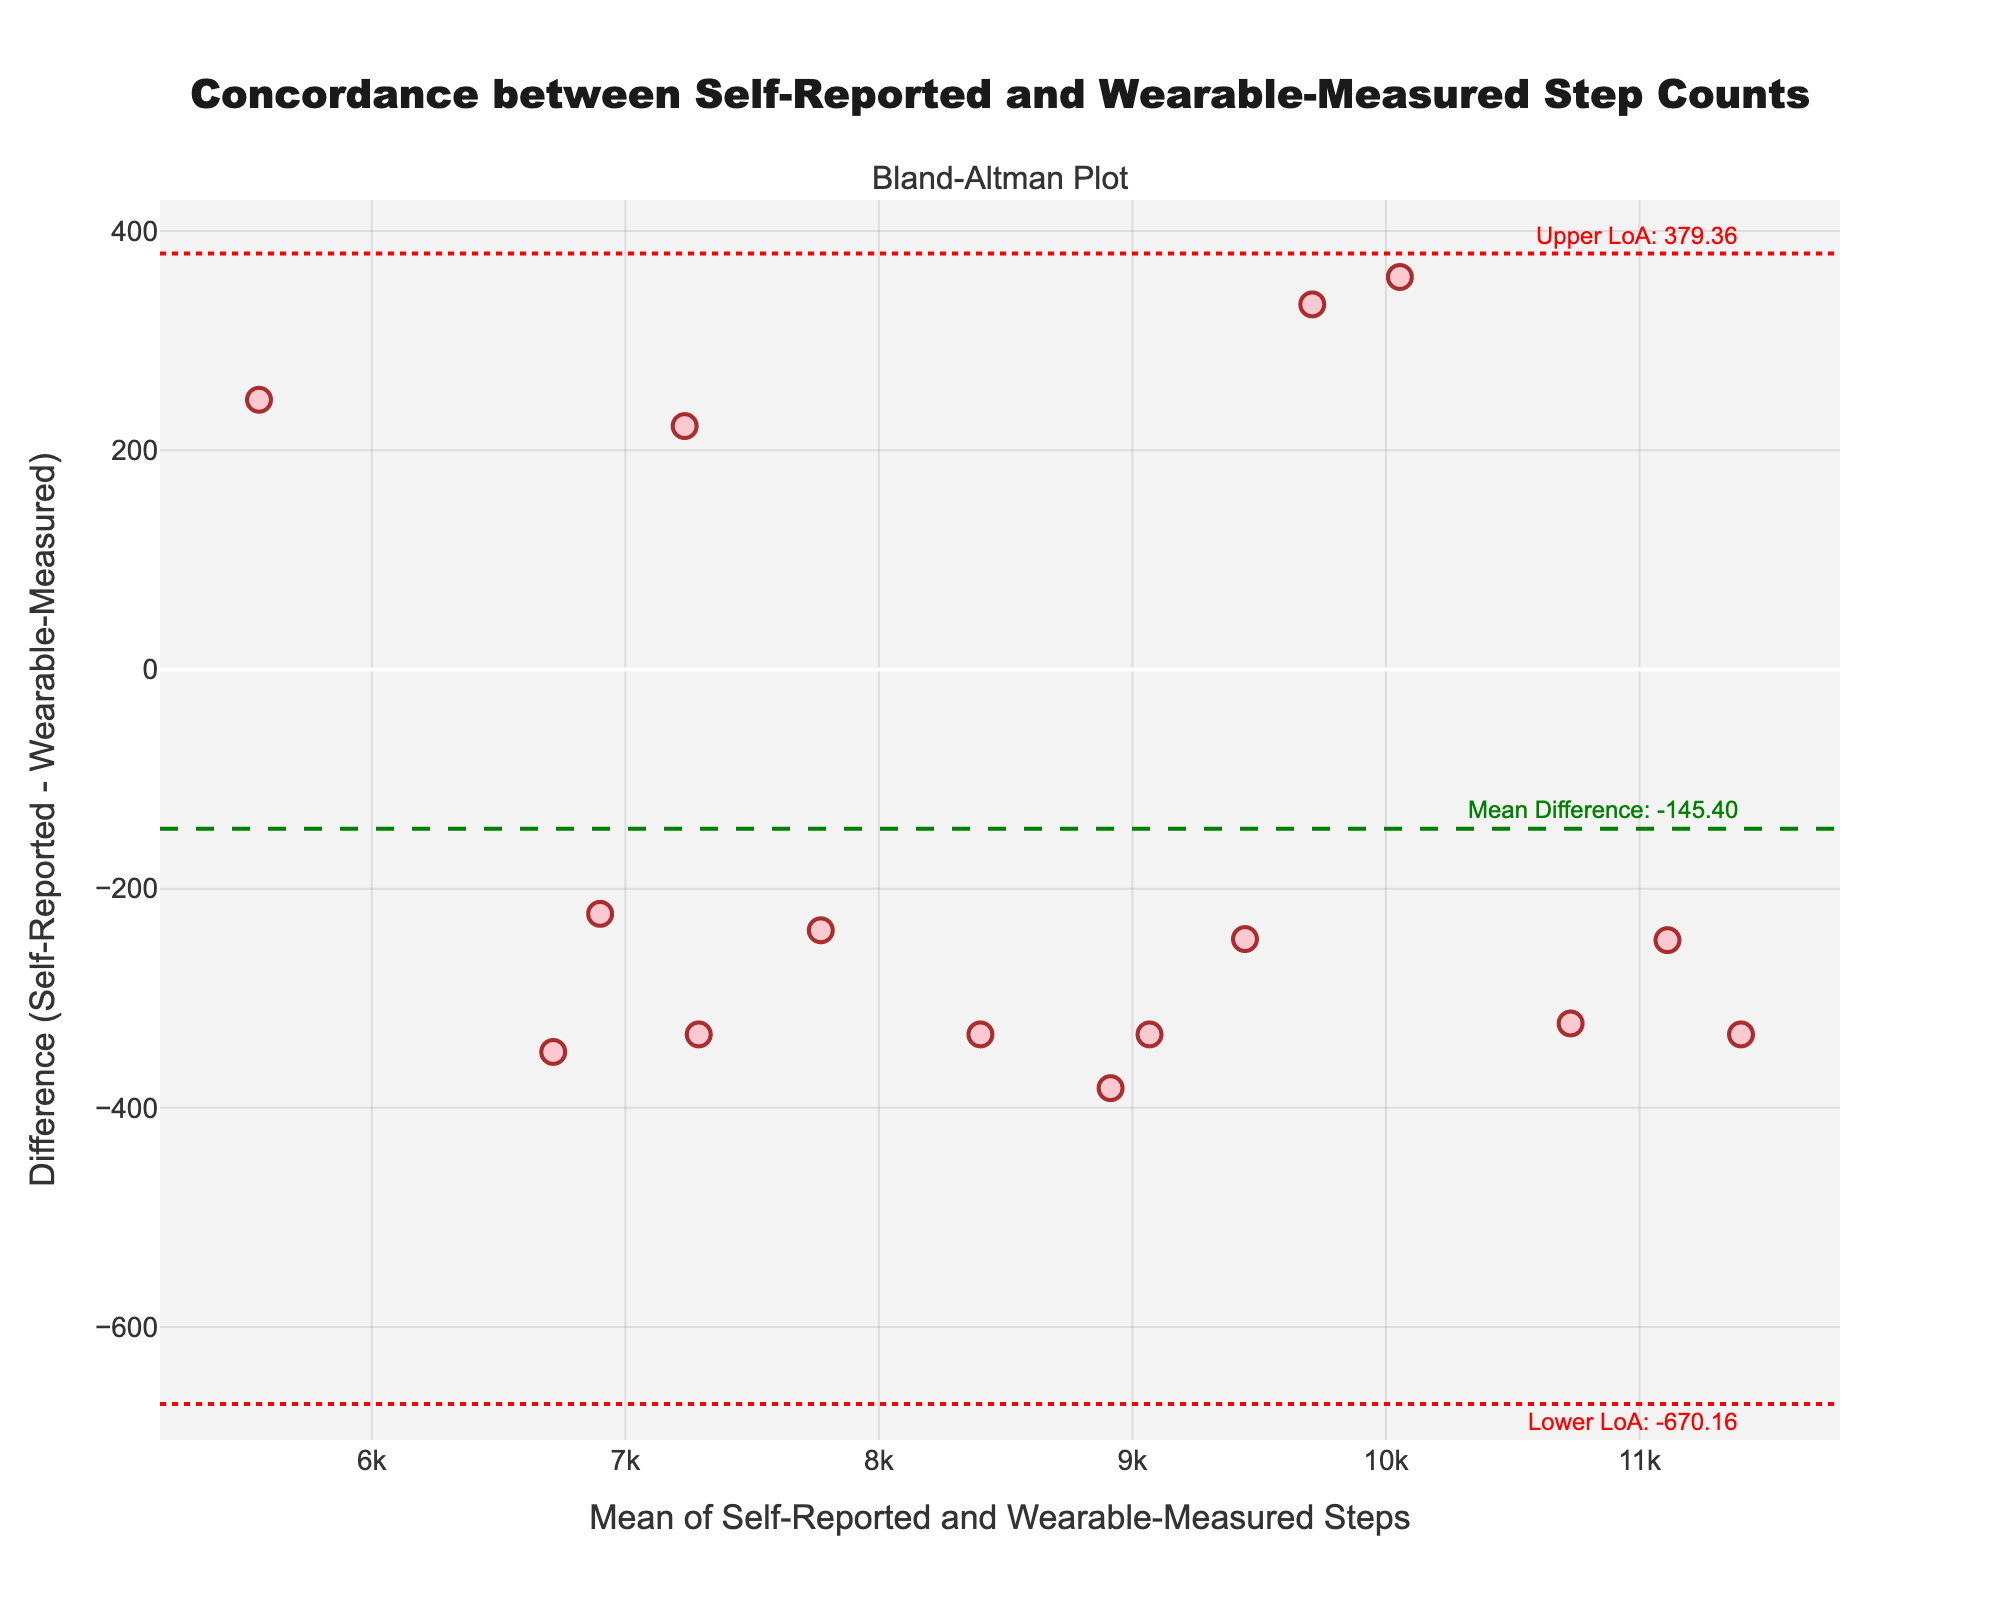How many data points are represented in the figure? Count the number of markers (data points) on the plot. The data contains 15 subjects, each contributing one data point.
Answer: 15 What is the title of the figure? The title of the figure is often at the top and centered. It states the main focus of the figure.
Answer: "Concordance between Self-Reported and Wearable-Measured Step Counts" What do the green and red dashed lines represent? The green dashed line represents the mean difference (mean discrepancy between self-reported and wearable-measured steps). The red dashed lines represent the limits of agreement (mean difference ± 1.96 standard deviations).
Answer: Mean difference and limits of agreement What is the value of the mean difference in step counts? Look at the green dashed line and the corresponding annotation at the right of the plot. The text reveals the mean difference value.
Answer: 160.13 What is the range between the upper and lower limits of agreement? Subtract the lower limit of agreement (lower red dashed line) from the upper limit of agreement (upper red dashed line).
Answer: 991.73 Who reported the highest number of steps? Find the data point with the largest mean value. Check the annotations to confirm the subject's identity.
Answer: George Taylor Which subject's self-reported steps underestimated the wearable-measured steps by the largest margin? Identify the data point with the lowest difference (most negative value). Check the corresponding annotation to confirm the subject's identity.
Answer: Fiona Wright Is there a general trend in the difference based on the mean step count? Observe whether data points above or below the mean difference line show any trend when moving from left to right on the x-axis.
Answer: No strong trend Do most data points fall within the limits of agreement? Count the number of data points that fall between the red dashed lines (limits of agreement). Compare this with the total number of data points.
Answer: Yes Which subject's data point is closest to having zero difference between self-reported and wearable-measured steps? Find the data point closest to the y=0 line (difference of 0) on the plot. Confirm by checking the corresponding subject.
Answer: Diana Lee 